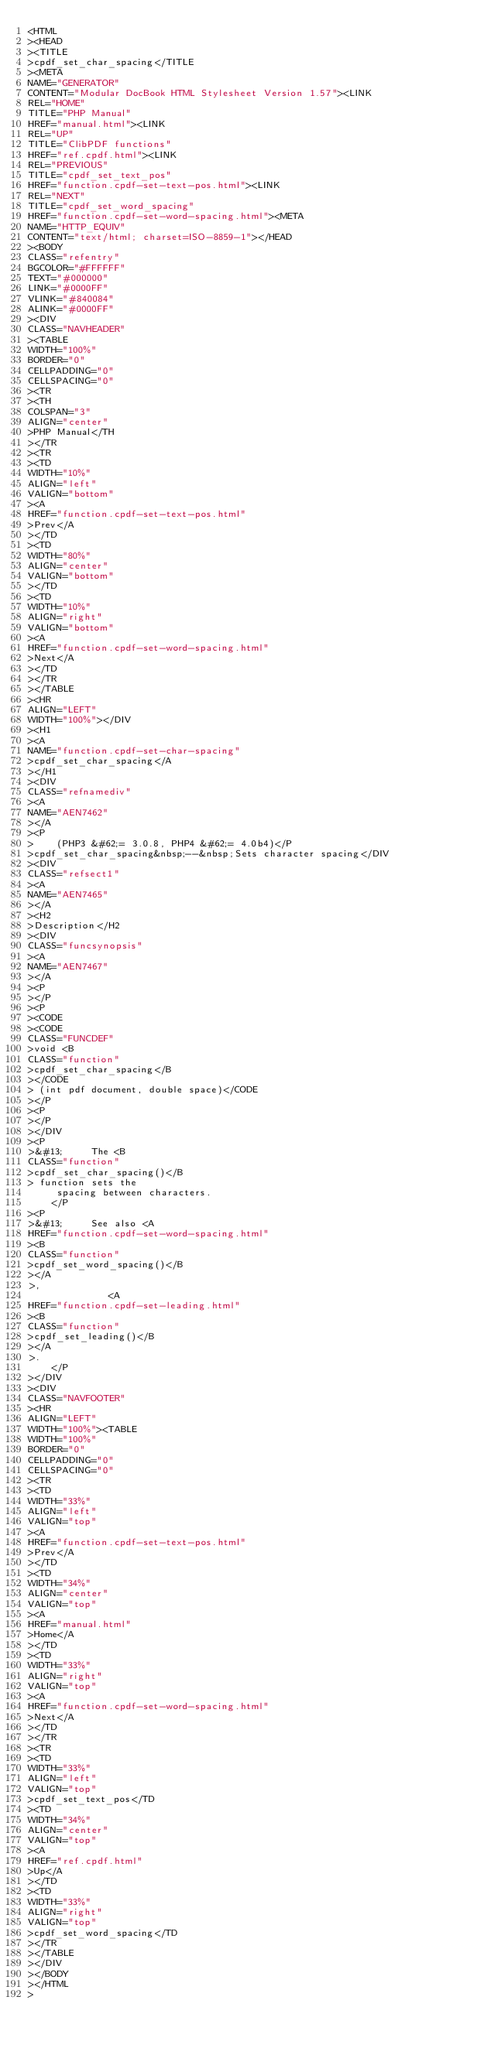Convert code to text. <code><loc_0><loc_0><loc_500><loc_500><_HTML_><HTML
><HEAD
><TITLE
>cpdf_set_char_spacing</TITLE
><META
NAME="GENERATOR"
CONTENT="Modular DocBook HTML Stylesheet Version 1.57"><LINK
REL="HOME"
TITLE="PHP Manual"
HREF="manual.html"><LINK
REL="UP"
TITLE="ClibPDF functions"
HREF="ref.cpdf.html"><LINK
REL="PREVIOUS"
TITLE="cpdf_set_text_pos"
HREF="function.cpdf-set-text-pos.html"><LINK
REL="NEXT"
TITLE="cpdf_set_word_spacing"
HREF="function.cpdf-set-word-spacing.html"><META
NAME="HTTP_EQUIV"
CONTENT="text/html; charset=ISO-8859-1"></HEAD
><BODY
CLASS="refentry"
BGCOLOR="#FFFFFF"
TEXT="#000000"
LINK="#0000FF"
VLINK="#840084"
ALINK="#0000FF"
><DIV
CLASS="NAVHEADER"
><TABLE
WIDTH="100%"
BORDER="0"
CELLPADDING="0"
CELLSPACING="0"
><TR
><TH
COLSPAN="3"
ALIGN="center"
>PHP Manual</TH
></TR
><TR
><TD
WIDTH="10%"
ALIGN="left"
VALIGN="bottom"
><A
HREF="function.cpdf-set-text-pos.html"
>Prev</A
></TD
><TD
WIDTH="80%"
ALIGN="center"
VALIGN="bottom"
></TD
><TD
WIDTH="10%"
ALIGN="right"
VALIGN="bottom"
><A
HREF="function.cpdf-set-word-spacing.html"
>Next</A
></TD
></TR
></TABLE
><HR
ALIGN="LEFT"
WIDTH="100%"></DIV
><H1
><A
NAME="function.cpdf-set-char-spacing"
>cpdf_set_char_spacing</A
></H1
><DIV
CLASS="refnamediv"
><A
NAME="AEN7462"
></A
><P
>    (PHP3 &#62;= 3.0.8, PHP4 &#62;= 4.0b4)</P
>cpdf_set_char_spacing&nbsp;--&nbsp;Sets character spacing</DIV
><DIV
CLASS="refsect1"
><A
NAME="AEN7465"
></A
><H2
>Description</H2
><DIV
CLASS="funcsynopsis"
><A
NAME="AEN7467"
></A
><P
></P
><P
><CODE
><CODE
CLASS="FUNCDEF"
>void <B
CLASS="function"
>cpdf_set_char_spacing</B
></CODE
> (int pdf document, double space)</CODE
></P
><P
></P
></DIV
><P
>&#13;     The <B
CLASS="function"
>cpdf_set_char_spacing()</B
> function sets the
     spacing between characters.
    </P
><P
>&#13;     See also <A
HREF="function.cpdf-set-word-spacing.html"
><B
CLASS="function"
>cpdf_set_word_spacing()</B
></A
>,
              <A
HREF="function.cpdf-set-leading.html"
><B
CLASS="function"
>cpdf_set_leading()</B
></A
>.
    </P
></DIV
><DIV
CLASS="NAVFOOTER"
><HR
ALIGN="LEFT"
WIDTH="100%"><TABLE
WIDTH="100%"
BORDER="0"
CELLPADDING="0"
CELLSPACING="0"
><TR
><TD
WIDTH="33%"
ALIGN="left"
VALIGN="top"
><A
HREF="function.cpdf-set-text-pos.html"
>Prev</A
></TD
><TD
WIDTH="34%"
ALIGN="center"
VALIGN="top"
><A
HREF="manual.html"
>Home</A
></TD
><TD
WIDTH="33%"
ALIGN="right"
VALIGN="top"
><A
HREF="function.cpdf-set-word-spacing.html"
>Next</A
></TD
></TR
><TR
><TD
WIDTH="33%"
ALIGN="left"
VALIGN="top"
>cpdf_set_text_pos</TD
><TD
WIDTH="34%"
ALIGN="center"
VALIGN="top"
><A
HREF="ref.cpdf.html"
>Up</A
></TD
><TD
WIDTH="33%"
ALIGN="right"
VALIGN="top"
>cpdf_set_word_spacing</TD
></TR
></TABLE
></DIV
></BODY
></HTML
></code> 